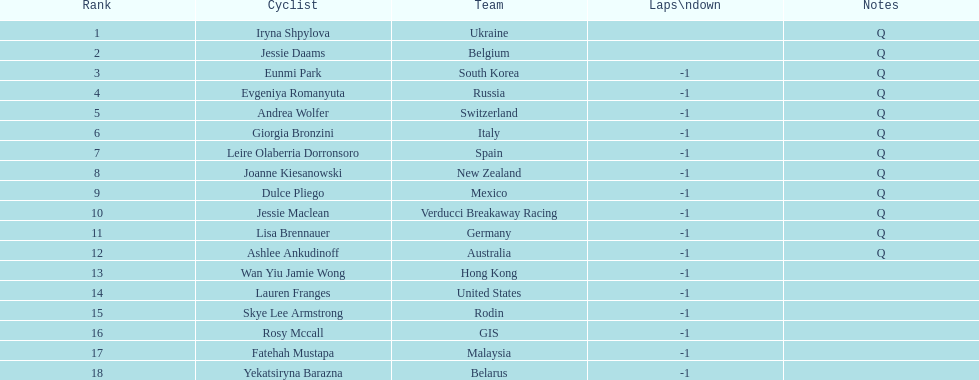Can you parse all the data within this table? {'header': ['Rank', 'Cyclist', 'Team', 'Laps\\ndown', 'Notes'], 'rows': [['1', 'Iryna Shpylova', 'Ukraine', '', 'Q'], ['2', 'Jessie Daams', 'Belgium', '', 'Q'], ['3', 'Eunmi Park', 'South Korea', '-1', 'Q'], ['4', 'Evgeniya Romanyuta', 'Russia', '-1', 'Q'], ['5', 'Andrea Wolfer', 'Switzerland', '-1', 'Q'], ['6', 'Giorgia Bronzini', 'Italy', '-1', 'Q'], ['7', 'Leire Olaberria Dorronsoro', 'Spain', '-1', 'Q'], ['8', 'Joanne Kiesanowski', 'New Zealand', '-1', 'Q'], ['9', 'Dulce Pliego', 'Mexico', '-1', 'Q'], ['10', 'Jessie Maclean', 'Verducci Breakaway Racing', '-1', 'Q'], ['11', 'Lisa Brennauer', 'Germany', '-1', 'Q'], ['12', 'Ashlee Ankudinoff', 'Australia', '-1', 'Q'], ['13', 'Wan Yiu Jamie Wong', 'Hong Kong', '-1', ''], ['14', 'Lauren Franges', 'United States', '-1', ''], ['15', 'Skye Lee Armstrong', 'Rodin', '-1', ''], ['16', 'Rosy Mccall', 'GIS', '-1', ''], ['17', 'Fatehah Mustapa', 'Malaysia', '-1', ''], ['18', 'Yekatsiryna Barazna', 'Belarus', '-1', '']]} How many bike riders are not -1 laps down? 2. 